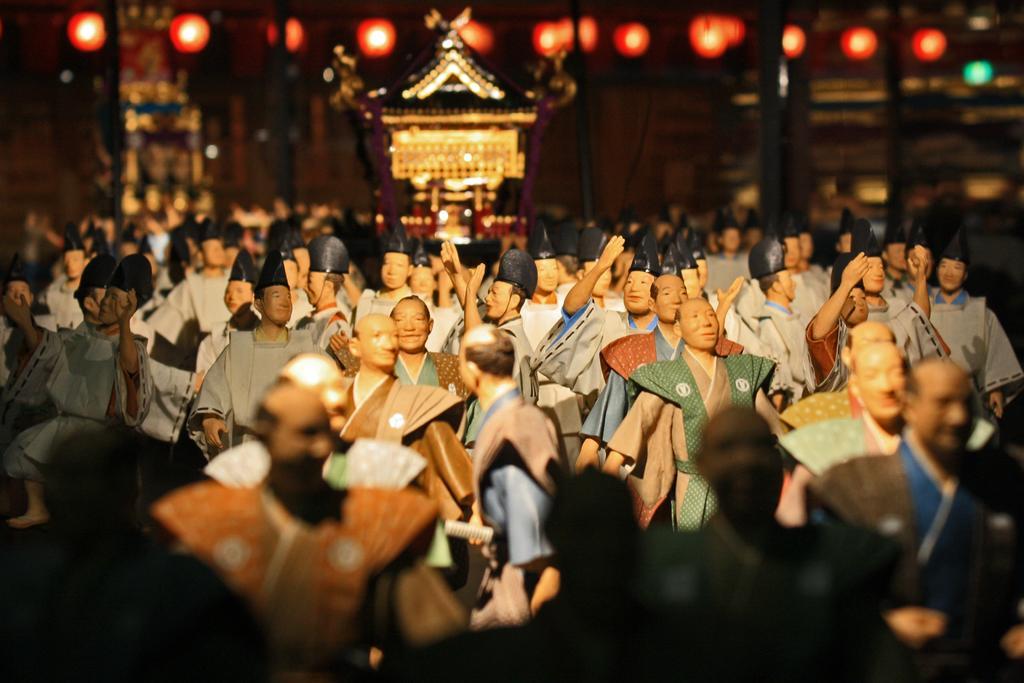How would you summarize this image in a sentence or two? In this picture I can see there are some wax dolls here, they are wearing clothes and some of them are wearing black hats and in the backdrop I can see there is a building and there is a wooden wall and a door. 